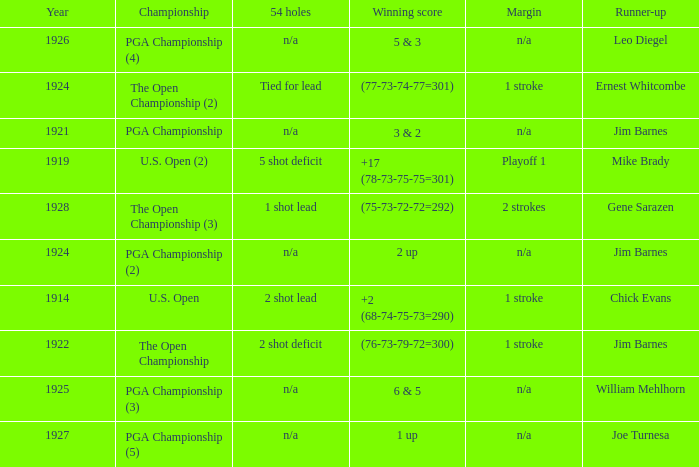In which year did mike brady achieve the runner-up position? 1919.0. 